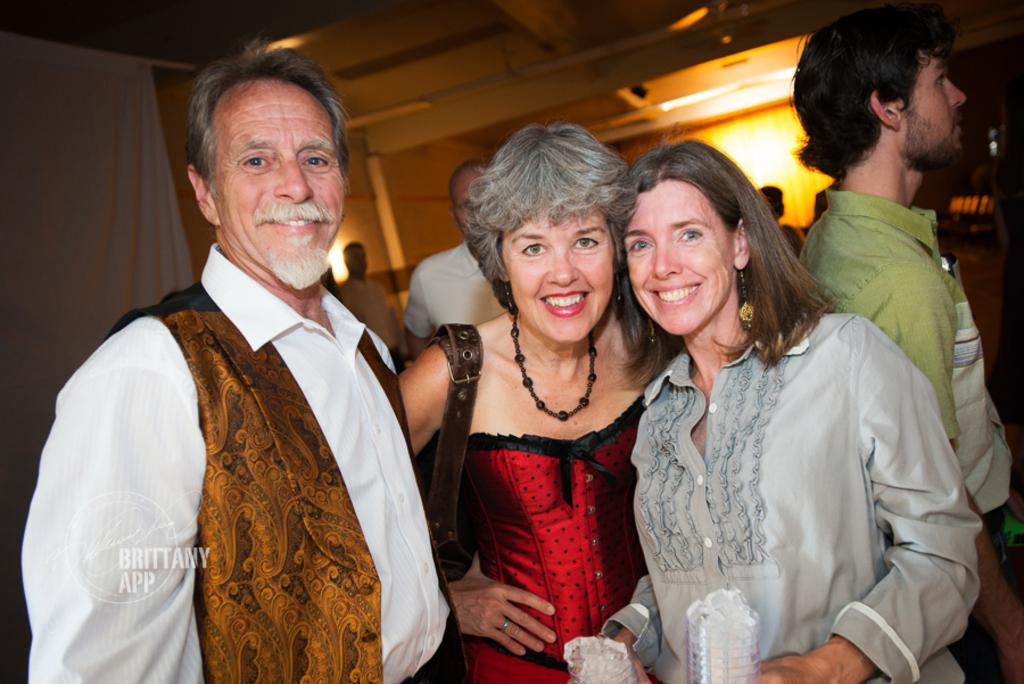Who or what can be seen in the image? There are people in the image. What is covering the window in the image? There is a curtain in the image. What is providing illumination in the image? There are lights in the image. What is the background of the image made of? There is a wall in the image. What else is present in the image besides the people, curtain, lights, and wall? There are objects in the image. What type of organization is responsible for the shocking shape of the objects in the image? There is no mention of any organization, shock, or shape in the image. The image only contains people, a curtain, lights, a wall, and objects. 